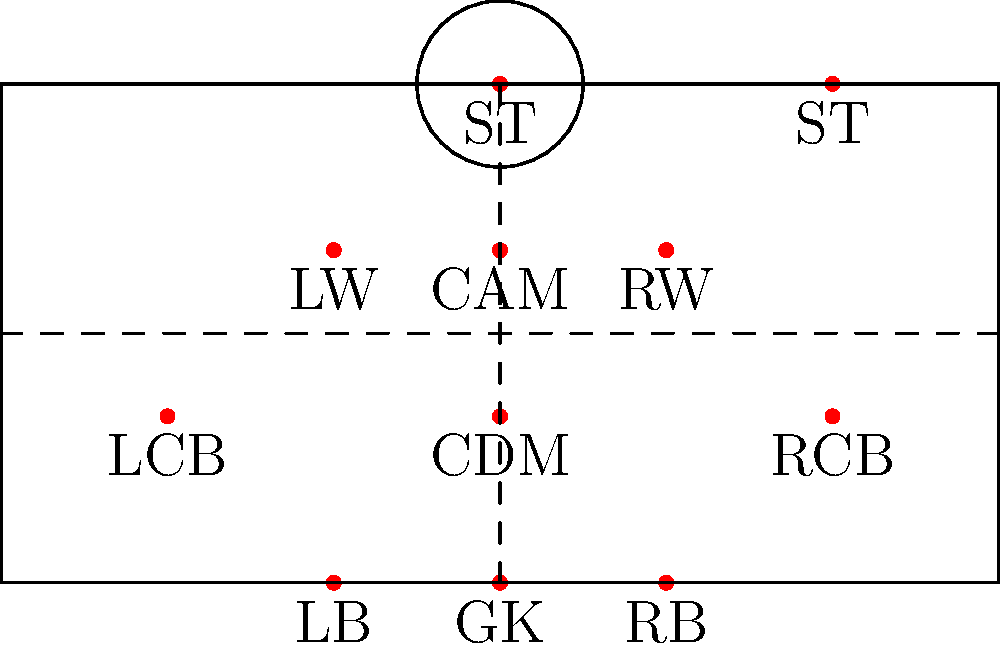In Brøndby IF's golden era of the late 1980s and early 1990s, which formation is represented in the diagram above, and how many strikers does it feature? To answer this question, let's analyze the diagram step-by-step:

1. First, we need to count the number of players in each line of the formation:
   - 1 player at the back (GK)
   - 4 players in the defensive line (RB, LCB, RCB, LB)
   - 1 player in the defensive midfield (CDM)
   - 3 players in the attacking midfield (CAM, LW, RW)
   - 2 players at the front (both labeled ST)

2. This arrangement of players represents a 4-1-3-2 formation.

3. To determine the number of strikers, we need to look at the topmost part of the formation:
   - There are two players labeled "ST" at the top of the formation.

4. In football terminology, "ST" stands for "Striker".

5. Therefore, this formation features 2 strikers.

This 4-1-3-2 formation was indeed popular during Brøndby IF's successful period in the late 1980s and early 1990s, known for its balanced approach combining solid defense with attacking prowess.
Answer: 4-1-3-2 formation with 2 strikers 